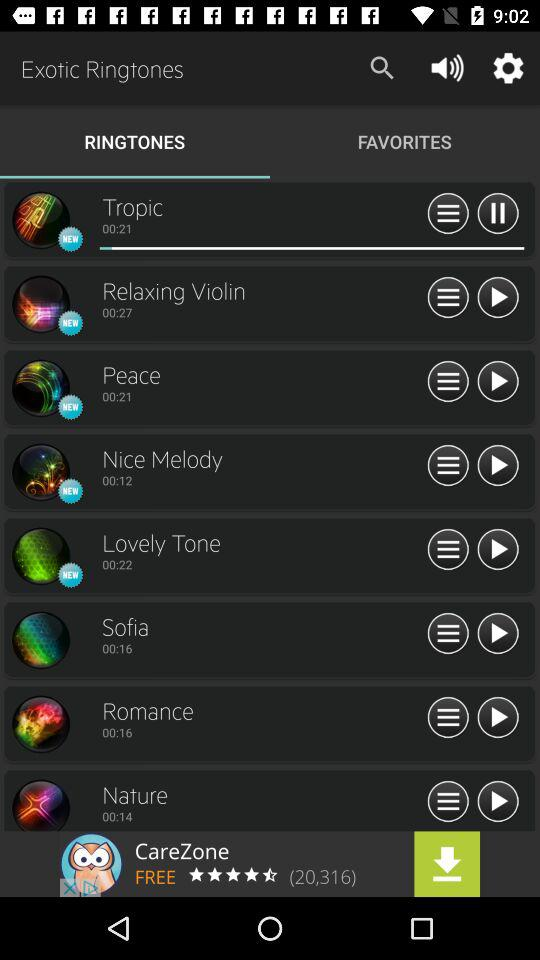Which ringtones are New in the system?
When the provided information is insufficient, respond with <no answer>. <no answer> 